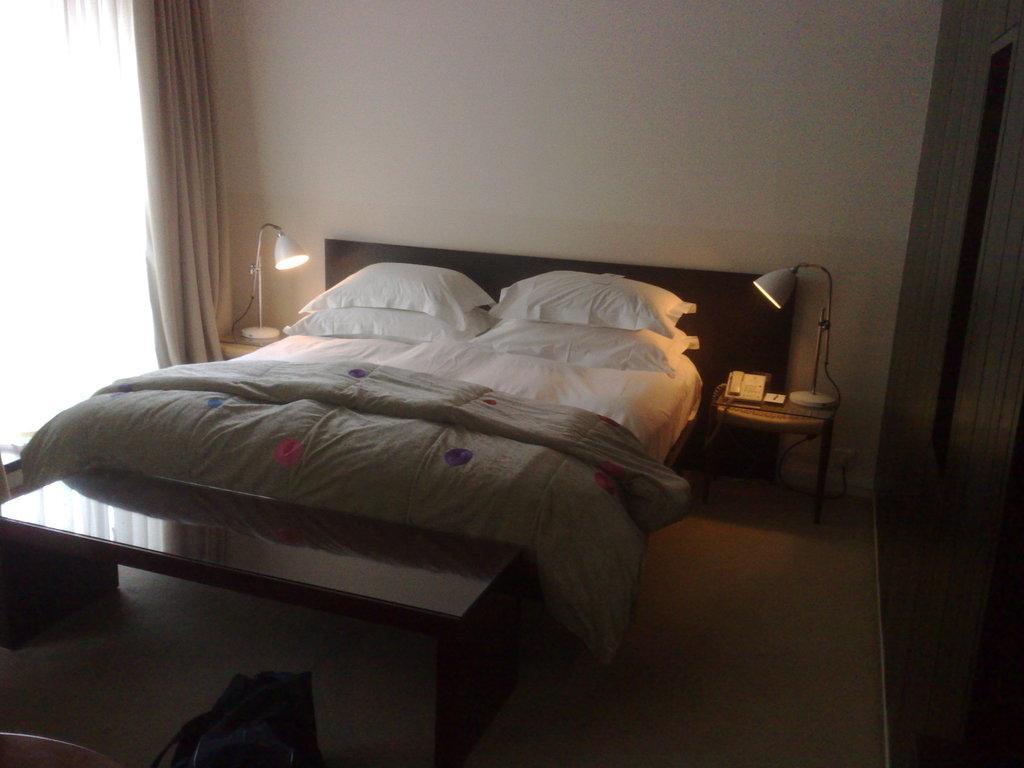Can you describe this image briefly? In this picture there is a bed with the blanket on it. And there are four pillows with white in color. And both side of the bed there is a lamp on the table. To the left side is a window with curtain. And to the right side there is a cupboard. On the right bottom there is a plug. In front of the bed there is a table. And to the bottom there is a bag 